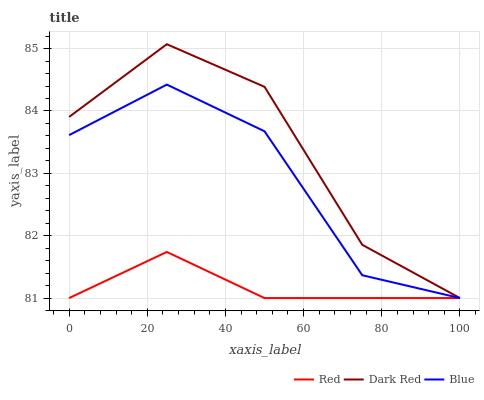Does Dark Red have the minimum area under the curve?
Answer yes or no. No. Does Red have the maximum area under the curve?
Answer yes or no. No. Is Dark Red the smoothest?
Answer yes or no. No. Is Red the roughest?
Answer yes or no. No. Does Red have the highest value?
Answer yes or no. No. 